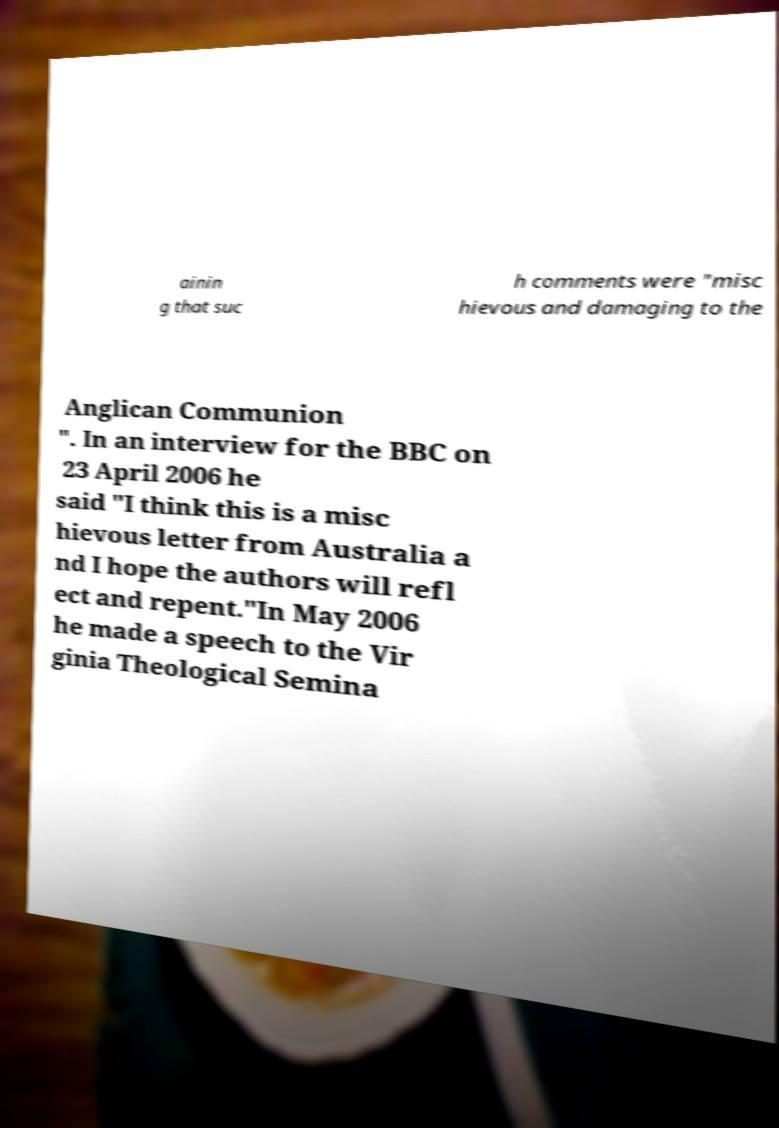For documentation purposes, I need the text within this image transcribed. Could you provide that? ainin g that suc h comments were "misc hievous and damaging to the Anglican Communion ". In an interview for the BBC on 23 April 2006 he said "I think this is a misc hievous letter from Australia a nd I hope the authors will refl ect and repent."In May 2006 he made a speech to the Vir ginia Theological Semina 